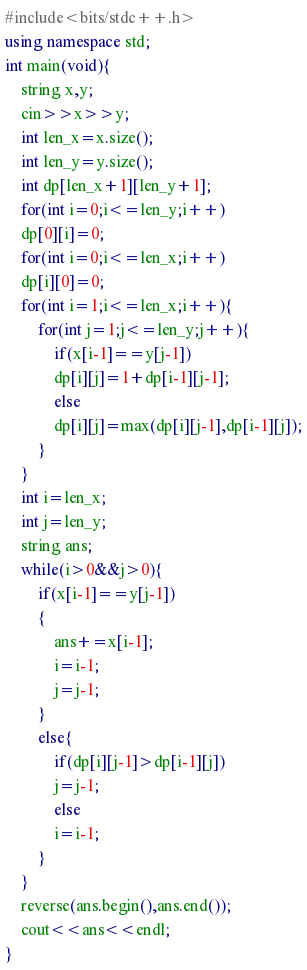Convert code to text. <code><loc_0><loc_0><loc_500><loc_500><_C++_>#include<bits/stdc++.h>
using namespace std;
int main(void){
    string x,y;
    cin>>x>>y;
    int len_x=x.size();
    int len_y=y.size();
    int dp[len_x+1][len_y+1];
    for(int i=0;i<=len_y;i++)
    dp[0][i]=0;
    for(int i=0;i<=len_x;i++)
    dp[i][0]=0;
    for(int i=1;i<=len_x;i++){
        for(int j=1;j<=len_y;j++){
            if(x[i-1]==y[j-1])
            dp[i][j]=1+dp[i-1][j-1];
            else
            dp[i][j]=max(dp[i][j-1],dp[i-1][j]);
        }
    }
    int i=len_x;
    int j=len_y;
    string ans;
    while(i>0&&j>0){
        if(x[i-1]==y[j-1])
        {
            ans+=x[i-1];
            i=i-1;
            j=j-1;
        }
        else{
            if(dp[i][j-1]>dp[i-1][j])
            j=j-1;
            else
            i=i-1;
        }
    }
    reverse(ans.begin(),ans.end());
    cout<<ans<<endl;
}</code> 